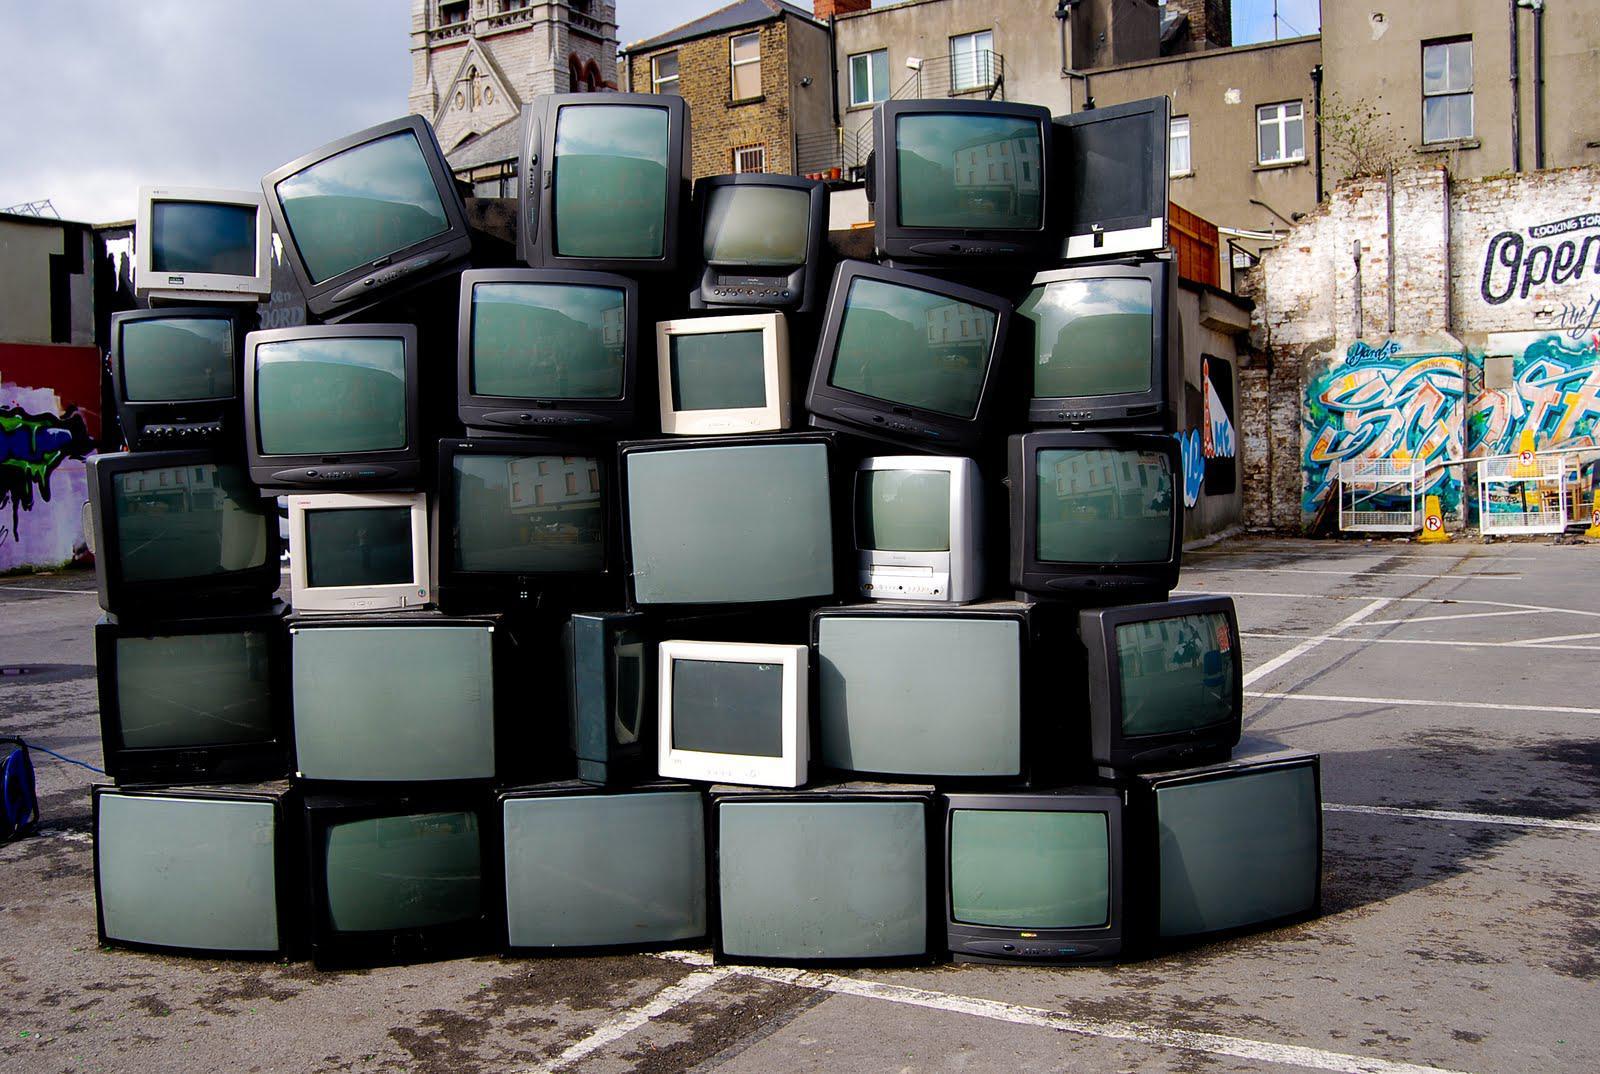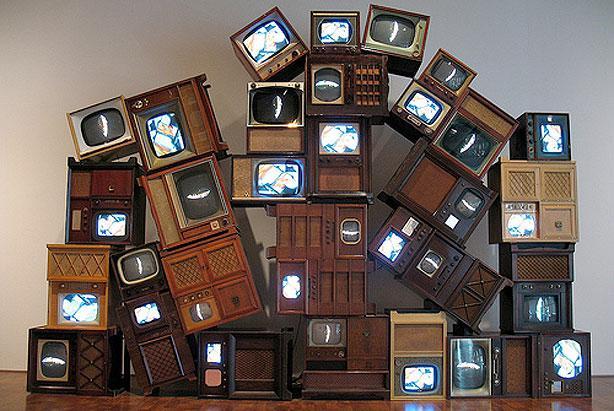The first image is the image on the left, the second image is the image on the right. For the images shown, is this caption "An image shows TV-type appliances piled in a room in front of pattered wallpaper." true? Answer yes or no. No. 